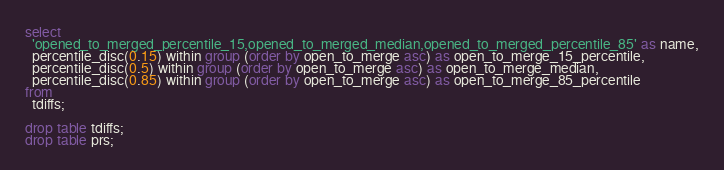<code> <loc_0><loc_0><loc_500><loc_500><_SQL_>
select
  'opened_to_merged_percentile_15,opened_to_merged_median,opened_to_merged_percentile_85' as name,
  percentile_disc(0.15) within group (order by open_to_merge asc) as open_to_merge_15_percentile,
  percentile_disc(0.5) within group (order by open_to_merge asc) as open_to_merge_median,
  percentile_disc(0.85) within group (order by open_to_merge asc) as open_to_merge_85_percentile
from
  tdiffs;

drop table tdiffs;
drop table prs;
</code> 